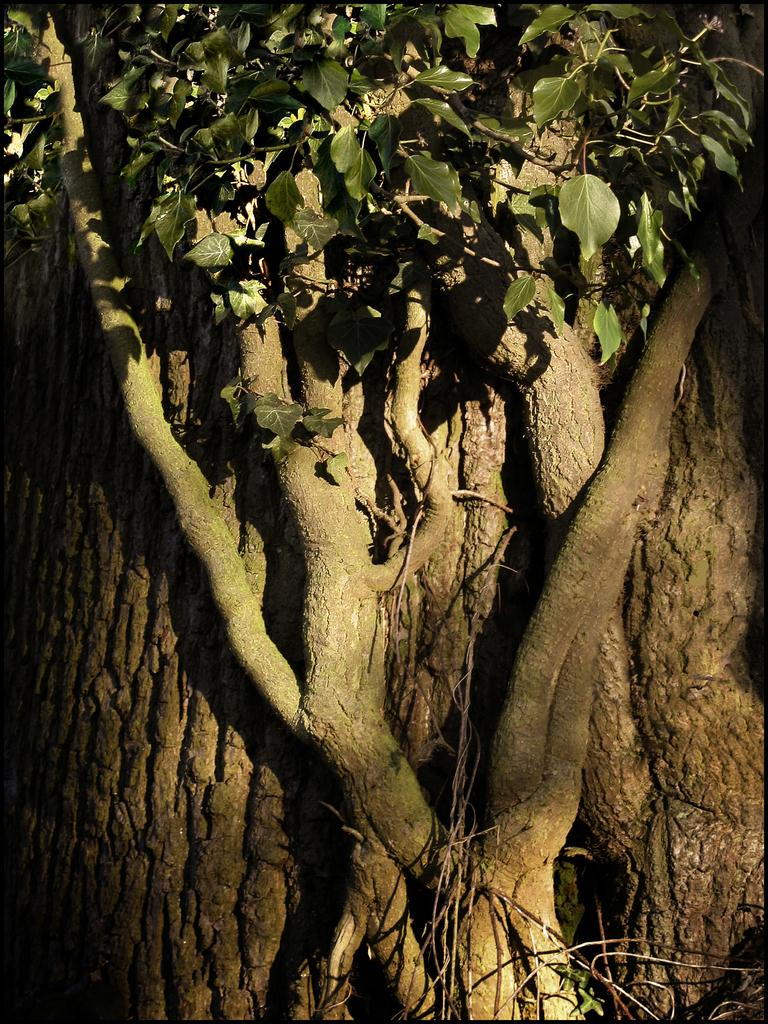What type of plant can be seen in the image? There is a tree in the image. What is the condition of the tree's foliage? The tree has leaves. Can you describe the tree's appearance in the image? The tree is partially covered. What type of pancake is being served at the tree in the image? There is no pancake present in the image; it features a tree with leaves. How does the tree attract the attention of passersby in the image? The tree does not actively attract attention in the image; it is simply a part of the scene. 